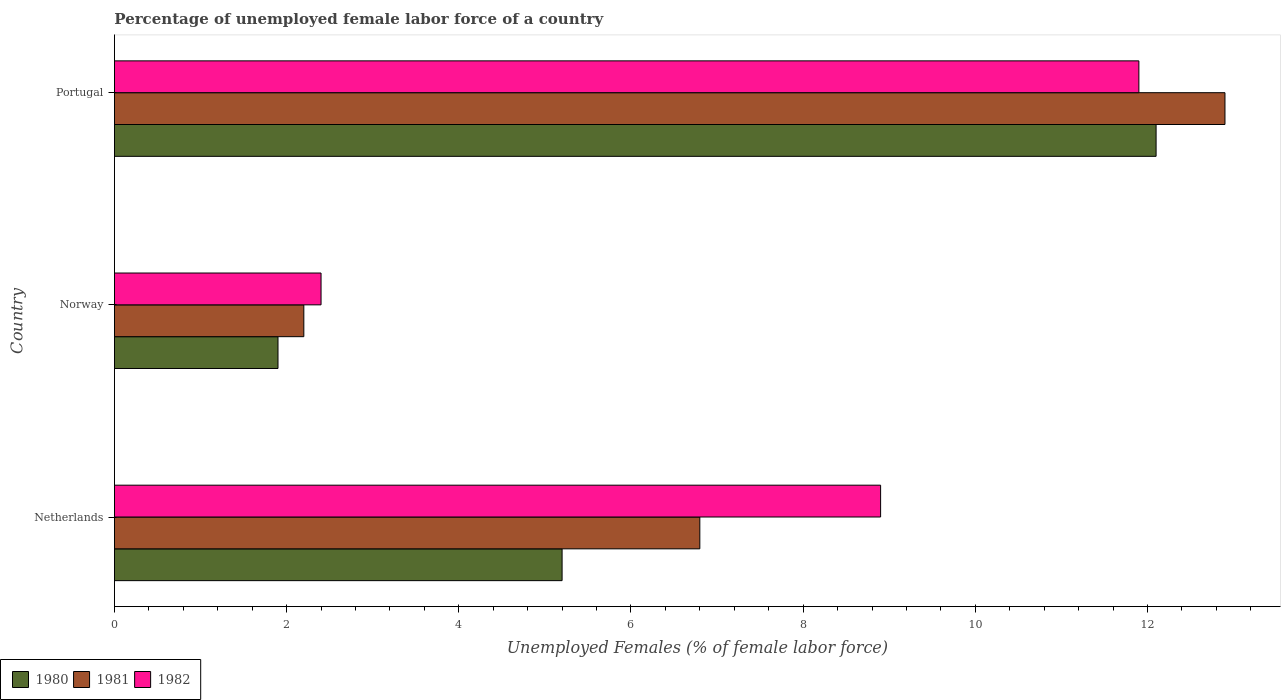How many groups of bars are there?
Offer a very short reply. 3. Are the number of bars on each tick of the Y-axis equal?
Provide a short and direct response. Yes. How many bars are there on the 2nd tick from the bottom?
Offer a very short reply. 3. In how many cases, is the number of bars for a given country not equal to the number of legend labels?
Make the answer very short. 0. What is the percentage of unemployed female labor force in 1980 in Portugal?
Provide a short and direct response. 12.1. Across all countries, what is the maximum percentage of unemployed female labor force in 1982?
Keep it short and to the point. 11.9. Across all countries, what is the minimum percentage of unemployed female labor force in 1981?
Your response must be concise. 2.2. In which country was the percentage of unemployed female labor force in 1981 minimum?
Give a very brief answer. Norway. What is the total percentage of unemployed female labor force in 1982 in the graph?
Your answer should be compact. 23.2. What is the difference between the percentage of unemployed female labor force in 1982 in Netherlands and that in Portugal?
Give a very brief answer. -3. What is the difference between the percentage of unemployed female labor force in 1981 in Netherlands and the percentage of unemployed female labor force in 1980 in Norway?
Provide a succinct answer. 4.9. What is the average percentage of unemployed female labor force in 1980 per country?
Keep it short and to the point. 6.4. What is the difference between the percentage of unemployed female labor force in 1981 and percentage of unemployed female labor force in 1980 in Netherlands?
Your response must be concise. 1.6. In how many countries, is the percentage of unemployed female labor force in 1982 greater than 7.6 %?
Ensure brevity in your answer.  2. What is the ratio of the percentage of unemployed female labor force in 1982 in Netherlands to that in Norway?
Offer a very short reply. 3.71. Is the percentage of unemployed female labor force in 1981 in Netherlands less than that in Portugal?
Make the answer very short. Yes. What is the difference between the highest and the second highest percentage of unemployed female labor force in 1981?
Ensure brevity in your answer.  6.1. What is the difference between the highest and the lowest percentage of unemployed female labor force in 1982?
Provide a succinct answer. 9.5. What does the 1st bar from the top in Portugal represents?
Your answer should be very brief. 1982. Are all the bars in the graph horizontal?
Offer a terse response. Yes. How many countries are there in the graph?
Your response must be concise. 3. What is the difference between two consecutive major ticks on the X-axis?
Provide a succinct answer. 2. Are the values on the major ticks of X-axis written in scientific E-notation?
Your response must be concise. No. Does the graph contain grids?
Ensure brevity in your answer.  No. How many legend labels are there?
Your response must be concise. 3. How are the legend labels stacked?
Your answer should be very brief. Horizontal. What is the title of the graph?
Offer a very short reply. Percentage of unemployed female labor force of a country. Does "1970" appear as one of the legend labels in the graph?
Your answer should be compact. No. What is the label or title of the X-axis?
Offer a very short reply. Unemployed Females (% of female labor force). What is the label or title of the Y-axis?
Keep it short and to the point. Country. What is the Unemployed Females (% of female labor force) of 1980 in Netherlands?
Provide a succinct answer. 5.2. What is the Unemployed Females (% of female labor force) of 1981 in Netherlands?
Provide a short and direct response. 6.8. What is the Unemployed Females (% of female labor force) of 1982 in Netherlands?
Your answer should be very brief. 8.9. What is the Unemployed Females (% of female labor force) of 1980 in Norway?
Ensure brevity in your answer.  1.9. What is the Unemployed Females (% of female labor force) of 1981 in Norway?
Offer a very short reply. 2.2. What is the Unemployed Females (% of female labor force) of 1982 in Norway?
Make the answer very short. 2.4. What is the Unemployed Females (% of female labor force) in 1980 in Portugal?
Your answer should be very brief. 12.1. What is the Unemployed Females (% of female labor force) in 1981 in Portugal?
Provide a succinct answer. 12.9. What is the Unemployed Females (% of female labor force) in 1982 in Portugal?
Offer a very short reply. 11.9. Across all countries, what is the maximum Unemployed Females (% of female labor force) of 1980?
Give a very brief answer. 12.1. Across all countries, what is the maximum Unemployed Females (% of female labor force) of 1981?
Offer a very short reply. 12.9. Across all countries, what is the maximum Unemployed Females (% of female labor force) of 1982?
Your response must be concise. 11.9. Across all countries, what is the minimum Unemployed Females (% of female labor force) of 1980?
Offer a terse response. 1.9. Across all countries, what is the minimum Unemployed Females (% of female labor force) of 1981?
Provide a short and direct response. 2.2. Across all countries, what is the minimum Unemployed Females (% of female labor force) of 1982?
Provide a succinct answer. 2.4. What is the total Unemployed Females (% of female labor force) of 1980 in the graph?
Keep it short and to the point. 19.2. What is the total Unemployed Females (% of female labor force) in 1981 in the graph?
Make the answer very short. 21.9. What is the total Unemployed Females (% of female labor force) of 1982 in the graph?
Make the answer very short. 23.2. What is the difference between the Unemployed Females (% of female labor force) of 1980 in Netherlands and that in Norway?
Provide a short and direct response. 3.3. What is the difference between the Unemployed Females (% of female labor force) of 1982 in Netherlands and that in Norway?
Offer a very short reply. 6.5. What is the difference between the Unemployed Females (% of female labor force) of 1980 in Norway and that in Portugal?
Ensure brevity in your answer.  -10.2. What is the difference between the Unemployed Females (% of female labor force) in 1982 in Norway and that in Portugal?
Keep it short and to the point. -9.5. What is the difference between the Unemployed Females (% of female labor force) in 1980 in Netherlands and the Unemployed Females (% of female labor force) in 1981 in Norway?
Make the answer very short. 3. What is the difference between the Unemployed Females (% of female labor force) in 1981 in Netherlands and the Unemployed Females (% of female labor force) in 1982 in Norway?
Offer a terse response. 4.4. What is the difference between the Unemployed Females (% of female labor force) of 1980 in Norway and the Unemployed Females (% of female labor force) of 1981 in Portugal?
Provide a succinct answer. -11. What is the difference between the Unemployed Females (% of female labor force) in 1980 in Norway and the Unemployed Females (% of female labor force) in 1982 in Portugal?
Offer a very short reply. -10. What is the average Unemployed Females (% of female labor force) in 1981 per country?
Offer a terse response. 7.3. What is the average Unemployed Females (% of female labor force) of 1982 per country?
Give a very brief answer. 7.73. What is the difference between the Unemployed Females (% of female labor force) of 1980 and Unemployed Females (% of female labor force) of 1981 in Netherlands?
Provide a short and direct response. -1.6. What is the difference between the Unemployed Females (% of female labor force) in 1980 and Unemployed Females (% of female labor force) in 1982 in Netherlands?
Make the answer very short. -3.7. What is the difference between the Unemployed Females (% of female labor force) in 1980 and Unemployed Females (% of female labor force) in 1982 in Norway?
Keep it short and to the point. -0.5. What is the difference between the Unemployed Females (% of female labor force) of 1981 and Unemployed Females (% of female labor force) of 1982 in Norway?
Your answer should be compact. -0.2. What is the difference between the Unemployed Females (% of female labor force) of 1980 and Unemployed Females (% of female labor force) of 1982 in Portugal?
Provide a succinct answer. 0.2. What is the ratio of the Unemployed Females (% of female labor force) of 1980 in Netherlands to that in Norway?
Ensure brevity in your answer.  2.74. What is the ratio of the Unemployed Females (% of female labor force) of 1981 in Netherlands to that in Norway?
Offer a very short reply. 3.09. What is the ratio of the Unemployed Females (% of female labor force) of 1982 in Netherlands to that in Norway?
Your answer should be very brief. 3.71. What is the ratio of the Unemployed Females (% of female labor force) in 1980 in Netherlands to that in Portugal?
Your answer should be very brief. 0.43. What is the ratio of the Unemployed Females (% of female labor force) of 1981 in Netherlands to that in Portugal?
Ensure brevity in your answer.  0.53. What is the ratio of the Unemployed Females (% of female labor force) in 1982 in Netherlands to that in Portugal?
Your answer should be compact. 0.75. What is the ratio of the Unemployed Females (% of female labor force) of 1980 in Norway to that in Portugal?
Offer a terse response. 0.16. What is the ratio of the Unemployed Females (% of female labor force) of 1981 in Norway to that in Portugal?
Provide a short and direct response. 0.17. What is the ratio of the Unemployed Females (% of female labor force) of 1982 in Norway to that in Portugal?
Offer a terse response. 0.2. What is the difference between the highest and the second highest Unemployed Females (% of female labor force) in 1980?
Your answer should be compact. 6.9. What is the difference between the highest and the second highest Unemployed Females (% of female labor force) in 1982?
Your response must be concise. 3. What is the difference between the highest and the lowest Unemployed Females (% of female labor force) in 1981?
Make the answer very short. 10.7. What is the difference between the highest and the lowest Unemployed Females (% of female labor force) of 1982?
Offer a terse response. 9.5. 